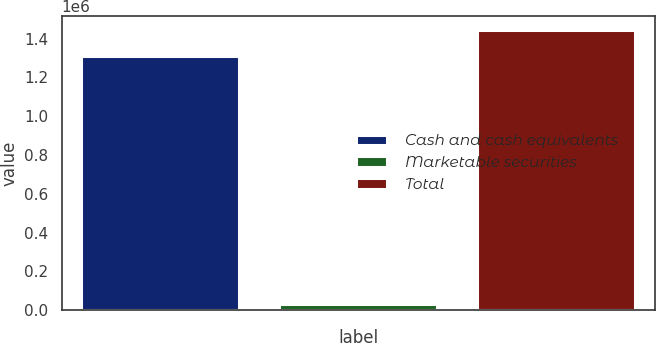Convert chart to OTSL. <chart><loc_0><loc_0><loc_500><loc_500><bar_chart><fcel>Cash and cash equivalents<fcel>Marketable securities<fcel>Total<nl><fcel>1.31335e+06<fcel>32860<fcel>1.44468e+06<nl></chart> 